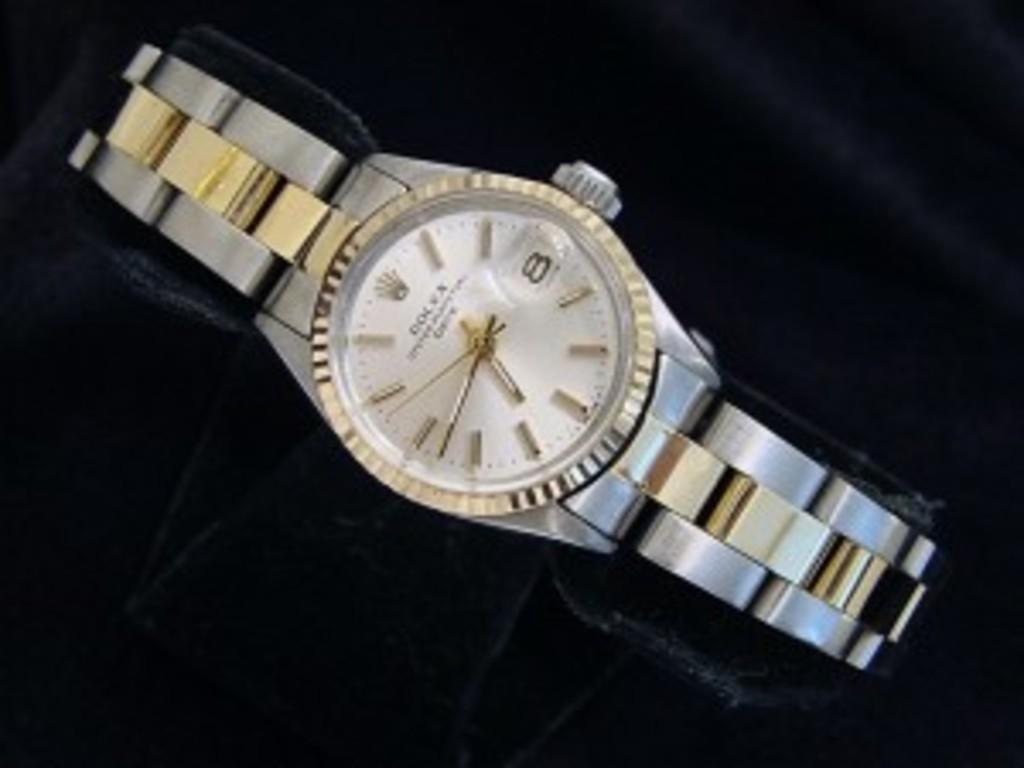<image>
Relay a brief, clear account of the picture shown. A Rolex watch is displayed on a black cloth. 